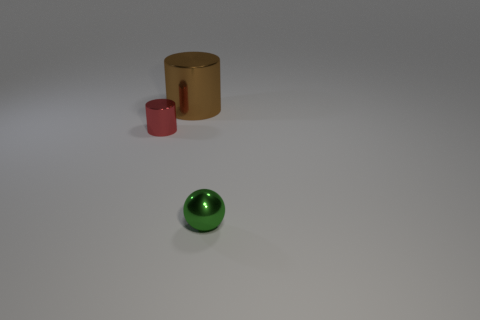Add 2 red objects. How many objects exist? 5 Subtract all balls. How many objects are left? 2 Subtract 0 blue spheres. How many objects are left? 3 Subtract all green shiny objects. Subtract all small cylinders. How many objects are left? 1 Add 3 cylinders. How many cylinders are left? 5 Add 2 small gray metallic cylinders. How many small gray metallic cylinders exist? 2 